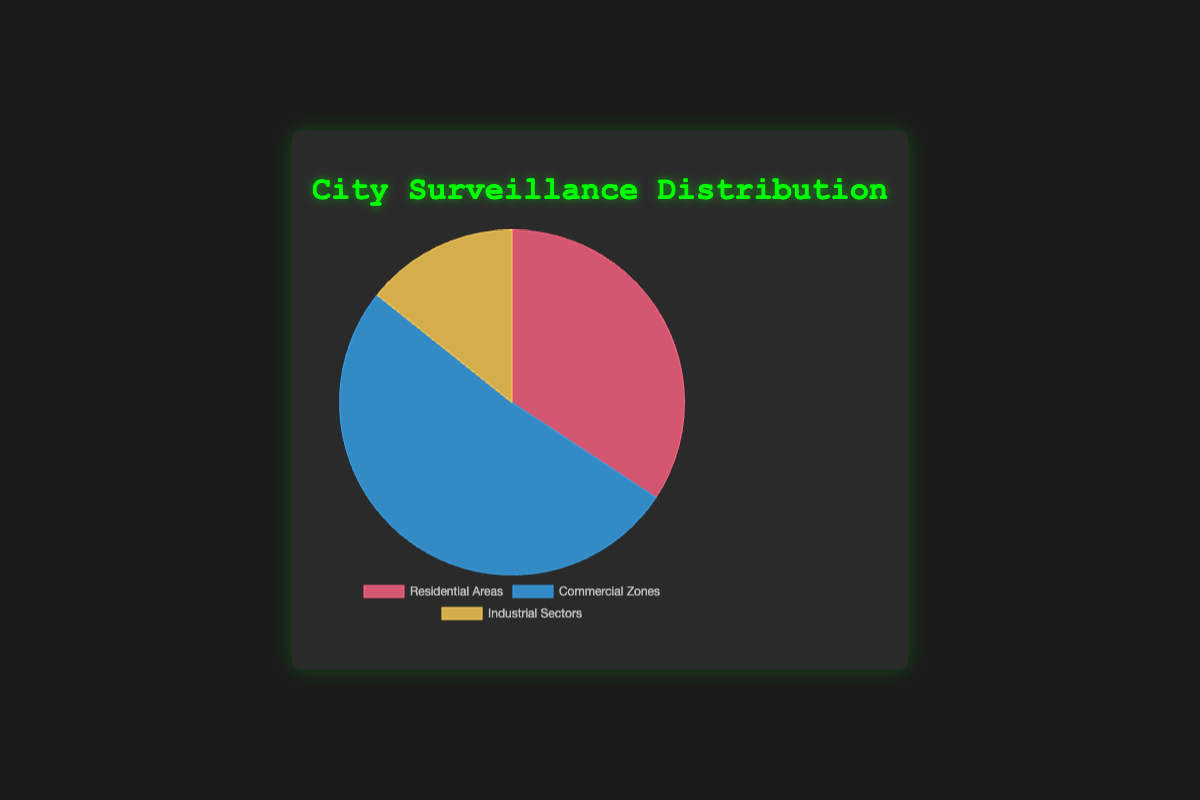Which area has the most surveillance cameras? By looking at the pie chart, we can see which segment occupies the largest portion. The Commercial Zones slice is the largest.
Answer: Commercial Zones How many more cameras are there in Residential Areas compared to Industrial Sectors? From the pie chart, Residential Areas have 1200 cameras and Industrial Sectors have 500. The difference is 1200 - 500.
Answer: 700 What is the total number of surveillance cameras across all areas? Add up the cameras from all areas: 1200 (Residential Areas) + 1800 (Commercial Zones) + 500 (Industrial Sectors) = 3500.
Answer: 3500 Which area has the least surveillance cameras? By examining the pie chart, the smallest slice represents the area with the least cameras. This is the Industrial Sectors.
Answer: Industrial Sectors What percentage of the total surveillance cameras are in Commercial Zones? Calculate the percentage by dividing the number of cameras in Commercial Zones by the total number of cameras and then multiplying by 100. (1800 / 3500) * 100 ≈ 51.43%.
Answer: 51.43% How does the number of cameras in Residential Areas compare to Commercial Zones? By comparing the two slices, Commercial Zones have more cameras than Residential Areas. Residential Areas have 1200 cameras, whereas Commercial Zones have 1800.
Answer: Commercial Zones have more If the total number of cameras were doubled, how many cameras would there be in Industrial Sectors? If the total number of cameras is doubled, Industrial Sectors would have twice their current number. 500 * 2 = 1000.
Answer: 1000 What is the difference in camera distribution size between the largest and smallest segments? The largest segment is Commercial Zones with 1800 cameras, and the smallest is Industrial Sectors with 500 cameras. The difference is 1800 - 500.
Answer: 1300 Which color represents the Residential Areas on the chart? By looking at the color-coded segments, we can identify the color corresponding to Residential Areas.
Answer: Red What is the average number of cameras per area? Calculate the average by dividing the total number of cameras by the number of areas. 3500 (total) / 3 (areas) = 1166.67.
Answer: 1166.67 